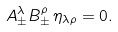<formula> <loc_0><loc_0><loc_500><loc_500>A _ { \pm } ^ { \lambda } B _ { \pm } ^ { \rho } \, \eta _ { \lambda \rho } = 0 .</formula> 